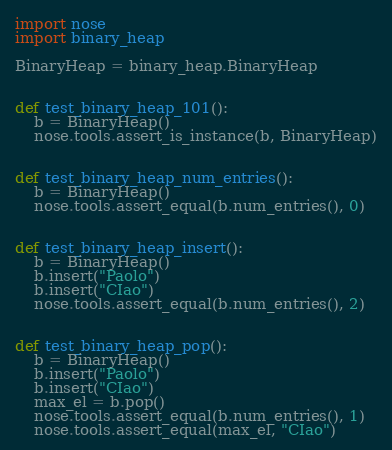Convert code to text. <code><loc_0><loc_0><loc_500><loc_500><_Python_>import nose
import binary_heap

BinaryHeap = binary_heap.BinaryHeap


def test_binary_heap_101():
    b = BinaryHeap()
    nose.tools.assert_is_instance(b, BinaryHeap)


def test_binary_heap_num_entries():
    b = BinaryHeap()
    nose.tools.assert_equal(b.num_entries(), 0)


def test_binary_heap_insert():
    b = BinaryHeap()
    b.insert("Paolo")
    b.insert("CIao")
    nose.tools.assert_equal(b.num_entries(), 2)


def test_binary_heap_pop():
    b = BinaryHeap()
    b.insert("Paolo")
    b.insert("CIao")
    max_el = b.pop()
    nose.tools.assert_equal(b.num_entries(), 1)
    nose.tools.assert_equal(max_el, "CIao")

</code> 